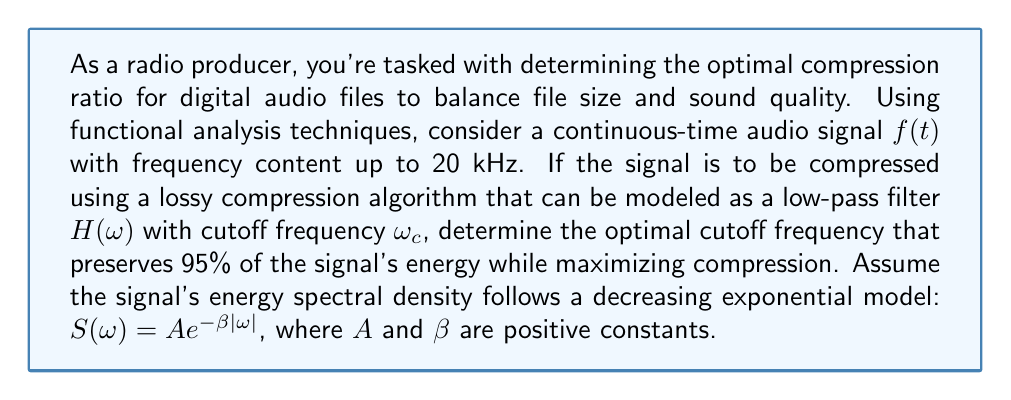Can you solve this math problem? To solve this problem, we'll use functional analysis techniques:

1) The total energy of the signal is given by Parseval's theorem:

   $$E_{\text{total}} = \int_{-\infty}^{\infty} |f(t)|^2 dt = \frac{1}{2\pi} \int_{-\infty}^{\infty} |F(\omega)|^2 d\omega = \frac{1}{2\pi} \int_{-\infty}^{\infty} S(\omega) d\omega$$

2) Given $S(\omega) = Ae^{-\beta|\omega|}$, we can calculate $E_{\text{total}}$:

   $$E_{\text{total}} = \frac{1}{2\pi} \int_{-\infty}^{\infty} Ae^{-\beta|\omega|} d\omega = \frac{A}{\pi} \int_{0}^{\infty} e^{-\beta\omega} d\omega = \frac{A}{\pi\beta}$$

3) The energy preserved after applying the low-pass filter $H(\omega)$ is:

   $$E_{\text{preserved}} = \frac{1}{2\pi} \int_{-\omega_c}^{\omega_c} S(\omega) d\omega = \frac{A}{\pi} \int_{0}^{\omega_c} e^{-\beta\omega} d\omega = \frac{A}{\pi\beta}(1 - e^{-\beta\omega_c})$$

4) We want to preserve 95% of the energy, so:

   $$\frac{E_{\text{preserved}}}{E_{\text{total}}} = \frac{\frac{A}{\pi\beta}(1 - e^{-\beta\omega_c})}{\frac{A}{\pi\beta}} = 1 - e^{-\beta\omega_c} = 0.95$$

5) Solving for $\omega_c$:

   $$e^{-\beta\omega_c} = 0.05$$
   $$-\beta\omega_c = \ln(0.05)$$
   $$\omega_c = -\frac{\ln(0.05)}{\beta} \approx \frac{3}{\beta}$$

6) The maximum frequency content is 20 kHz, so $\omega_{\text{max}} = 2\pi \cdot 20000 \approx 125664$ rad/s.

7) To determine $\beta$, we can use the fact that $S(\omega_{\text{max}}) \approx 0$:

   $$Ae^{-\beta\omega_{\text{max}}} \approx 0$$
   $$e^{-\beta\omega_{\text{max}}} \approx 0.01 \text{ (choosing a small value)}$$
   $$\beta \approx \frac{-\ln(0.01)}{\omega_{\text{max}}} \approx \frac{4.6}{125664} \approx 3.66 \times 10^{-5}$$

8) Therefore, the optimal cutoff frequency is:

   $$\omega_c \approx \frac{3}{\beta} \approx \frac{3}{3.66 \times 10^{-5}} \approx 82000 \text{ rad/s}$$

9) Converting to Hz:

   $$f_c = \frac{\omega_c}{2\pi} \approx 13052 \text{ Hz}$$

This cutoff frequency preserves 95% of the signal's energy while maximizing compression.
Answer: The optimal cutoff frequency for the low-pass filter is approximately 13052 Hz, which preserves 95% of the signal's energy while maximizing compression. 